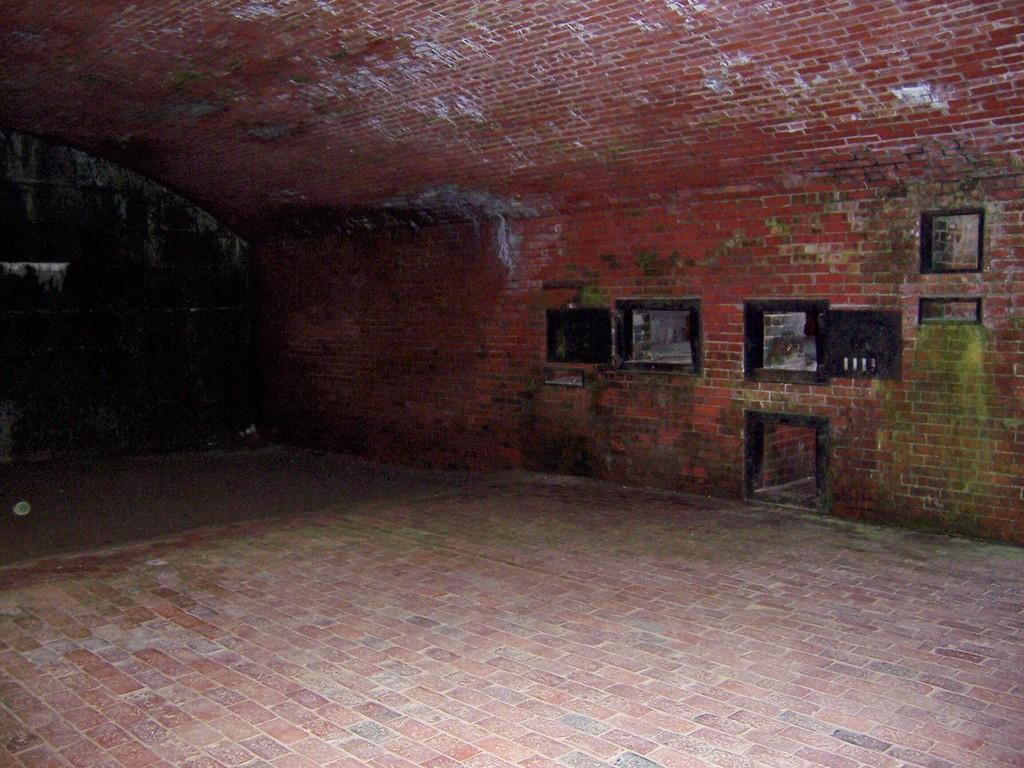What type of surface is visible at the bottom of the image? The image contains a floor. What can be seen on the wall in the image? There are objects on the wall in the image. What structure is visible at the top of the image? The image includes a roof. How would you describe the lighting in the image? The background of the image is dark. What type of badge is being displayed on the wall in the image? There is no badge present in the image. What is the average income of the people in the image? The image does not provide any information about the income of the people in the image. 